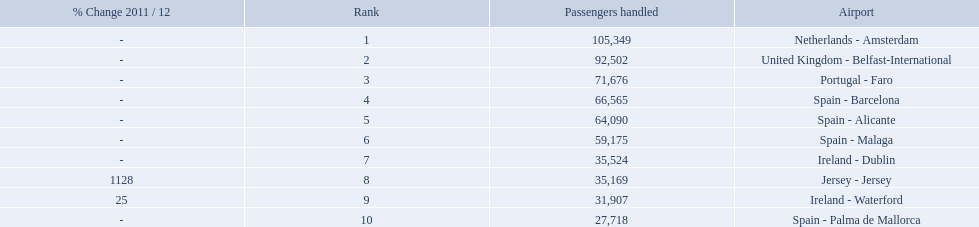What are the 10 busiest routes to and from london southend airport? Netherlands - Amsterdam, United Kingdom - Belfast-International, Portugal - Faro, Spain - Barcelona, Spain - Alicante, Spain - Malaga, Ireland - Dublin, Jersey - Jersey, Ireland - Waterford, Spain - Palma de Mallorca. Of these, which airport is in portugal? Portugal - Faro. 